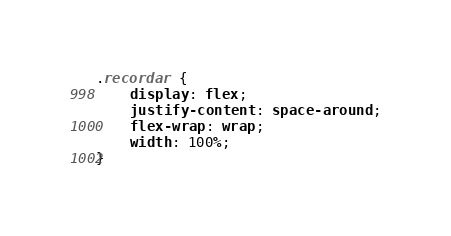Convert code to text. <code><loc_0><loc_0><loc_500><loc_500><_CSS_>.recordar {
    display: flex;
    justify-content: space-around;
    flex-wrap: wrap;
    width: 100%;
}</code> 